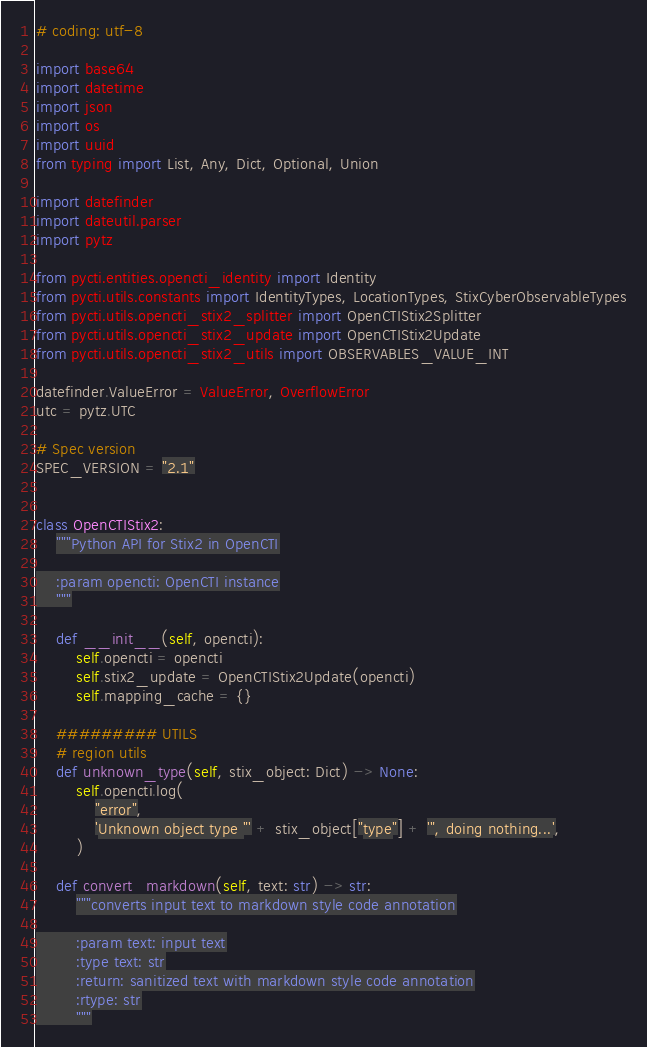<code> <loc_0><loc_0><loc_500><loc_500><_Python_># coding: utf-8

import base64
import datetime
import json
import os
import uuid
from typing import List, Any, Dict, Optional, Union

import datefinder
import dateutil.parser
import pytz

from pycti.entities.opencti_identity import Identity
from pycti.utils.constants import IdentityTypes, LocationTypes, StixCyberObservableTypes
from pycti.utils.opencti_stix2_splitter import OpenCTIStix2Splitter
from pycti.utils.opencti_stix2_update import OpenCTIStix2Update
from pycti.utils.opencti_stix2_utils import OBSERVABLES_VALUE_INT

datefinder.ValueError = ValueError, OverflowError
utc = pytz.UTC

# Spec version
SPEC_VERSION = "2.1"


class OpenCTIStix2:
    """Python API for Stix2 in OpenCTI

    :param opencti: OpenCTI instance
    """

    def __init__(self, opencti):
        self.opencti = opencti
        self.stix2_update = OpenCTIStix2Update(opencti)
        self.mapping_cache = {}

    ######### UTILS
    # region utils
    def unknown_type(self, stix_object: Dict) -> None:
        self.opencti.log(
            "error",
            'Unknown object type "' + stix_object["type"] + '", doing nothing...',
        )

    def convert_markdown(self, text: str) -> str:
        """converts input text to markdown style code annotation

        :param text: input text
        :type text: str
        :return: sanitized text with markdown style code annotation
        :rtype: str
        """
</code> 